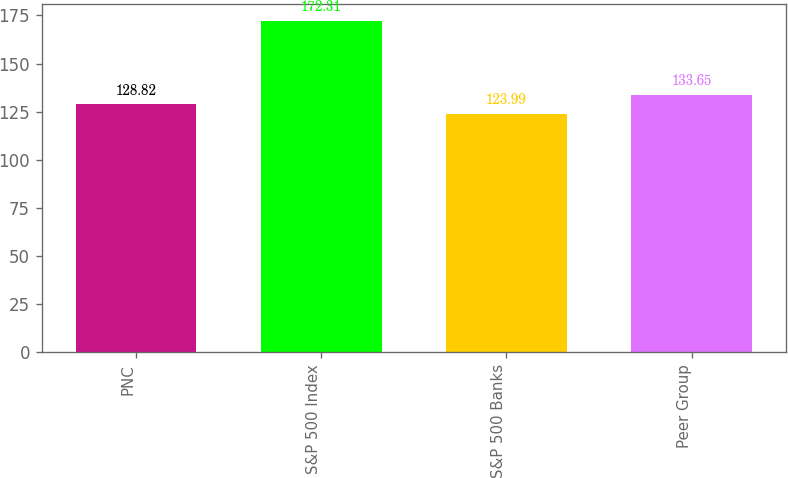Convert chart. <chart><loc_0><loc_0><loc_500><loc_500><bar_chart><fcel>PNC<fcel>S&P 500 Index<fcel>S&P 500 Banks<fcel>Peer Group<nl><fcel>128.82<fcel>172.31<fcel>123.99<fcel>133.65<nl></chart> 